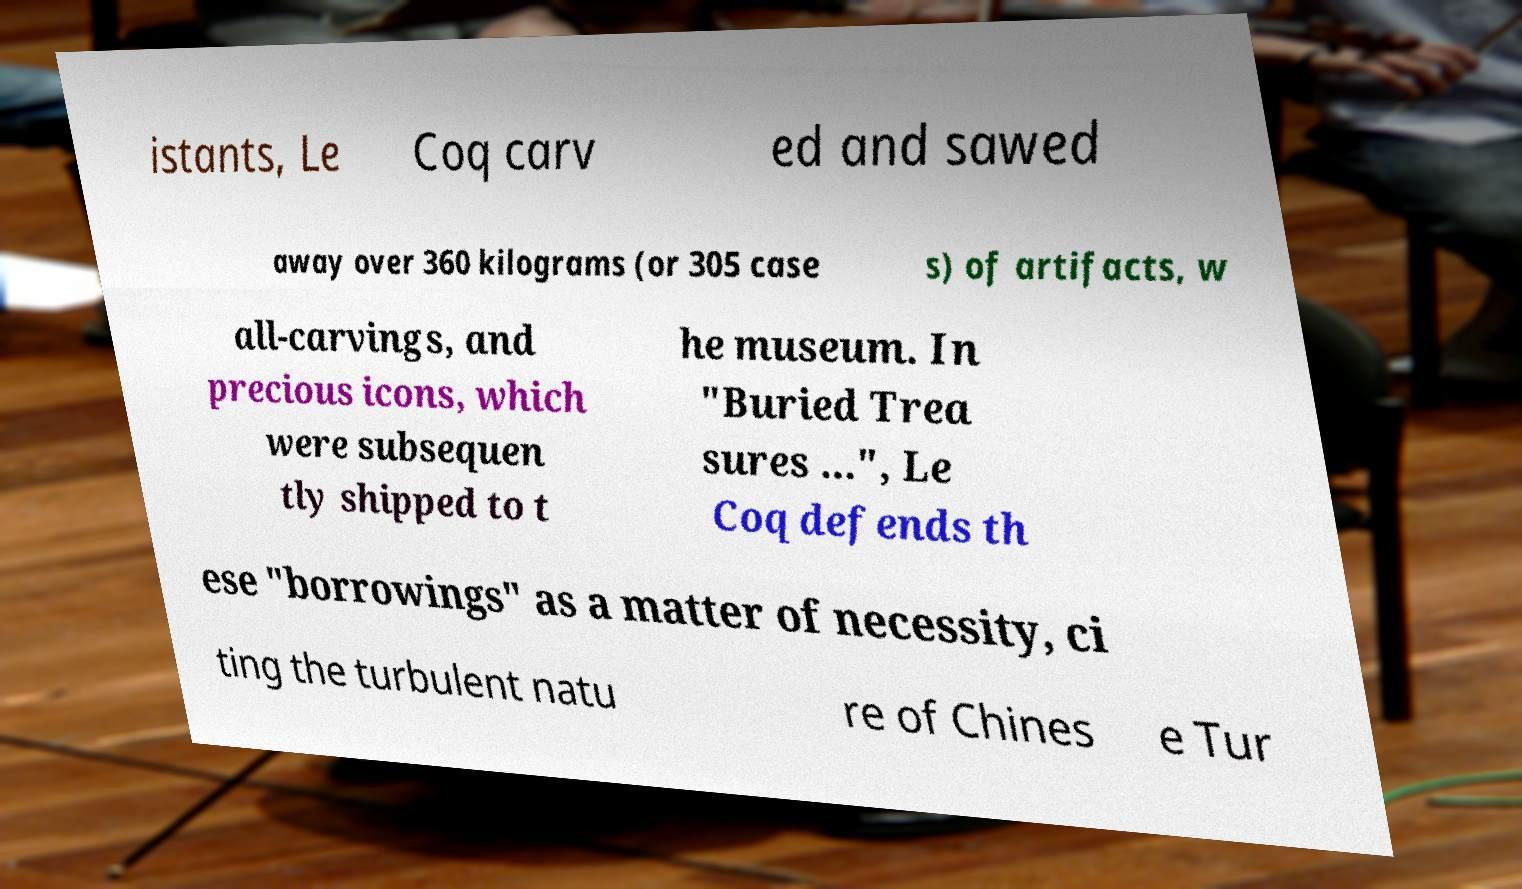Please identify and transcribe the text found in this image. istants, Le Coq carv ed and sawed away over 360 kilograms (or 305 case s) of artifacts, w all-carvings, and precious icons, which were subsequen tly shipped to t he museum. In "Buried Trea sures ...", Le Coq defends th ese "borrowings" as a matter of necessity, ci ting the turbulent natu re of Chines e Tur 